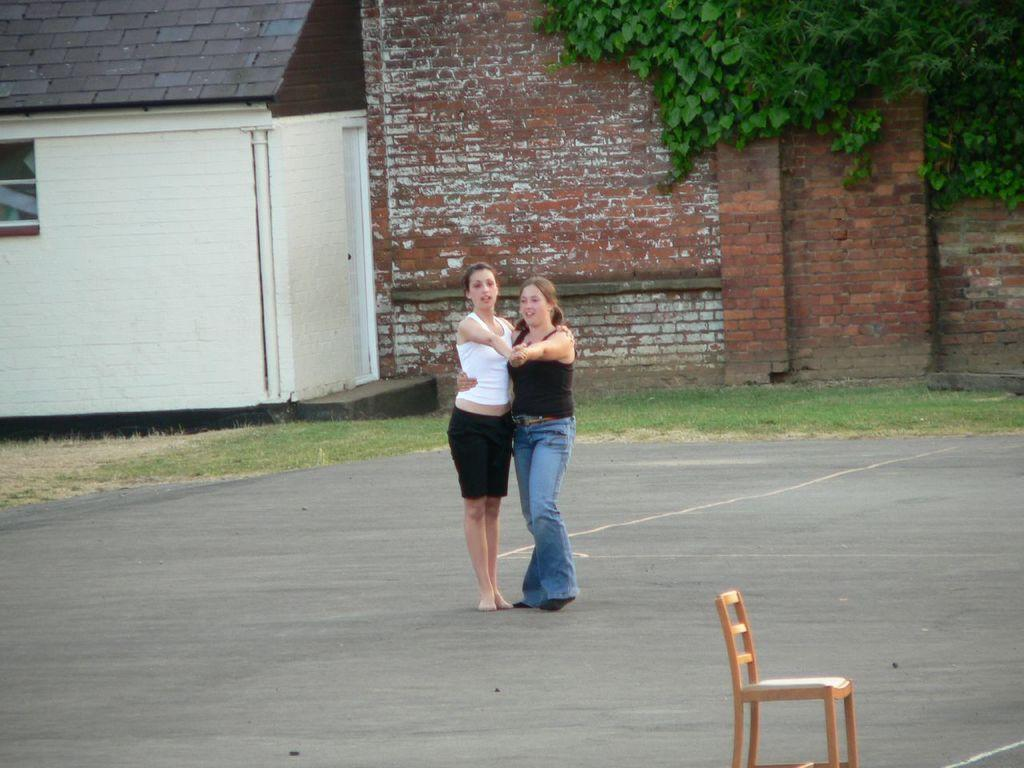How many people are in the image? There are two women in the image. What are the women doing in the image? The women are dancing. Where is the image set? The location is a parking lot. What type of hen can be seen in the image? There is no hen present in the image; it features two women dancing in a parking lot. 